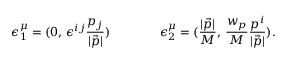Convert formula to latex. <formula><loc_0><loc_0><loc_500><loc_500>\epsilon _ { 1 } ^ { \mu } = ( 0 , \, \epsilon ^ { i j } \frac { { p } _ { j } } { | \vec { p } | } ) \quad \epsilon _ { 2 } ^ { \mu } = ( \frac { | \vec { p } | } { M } , \, \frac { w _ { p } } { M } \frac { { p } ^ { i } } { | \vec { p } | } ) .</formula> 